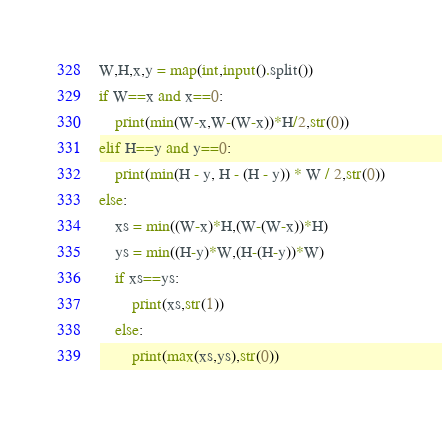Convert code to text. <code><loc_0><loc_0><loc_500><loc_500><_Python_>W,H,x,y = map(int,input().split())
if W==x and x==0:
    print(min(W-x,W-(W-x))*H/2,str(0))
elif H==y and y==0:
    print(min(H - y, H - (H - y)) * W / 2,str(0))
else:
    xs = min((W-x)*H,(W-(W-x))*H)
    ys = min((H-y)*W,(H-(H-y))*W)
    if xs==ys:
        print(xs,str(1))
    else:
        print(max(xs,ys),str(0))</code> 